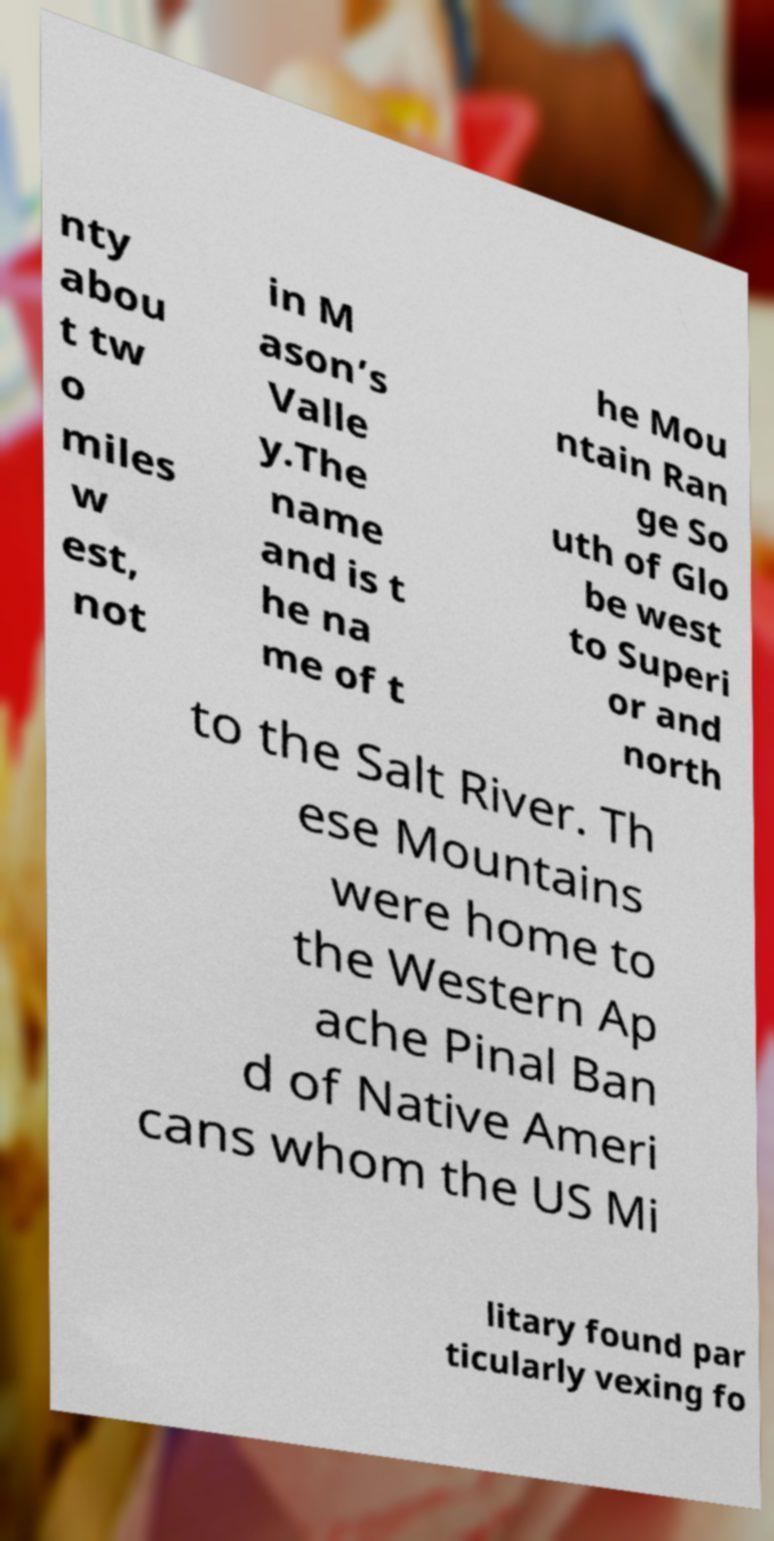There's text embedded in this image that I need extracted. Can you transcribe it verbatim? nty abou t tw o miles w est, not in M ason’s Valle y.The name and is t he na me of t he Mou ntain Ran ge So uth of Glo be west to Superi or and north to the Salt River. Th ese Mountains were home to the Western Ap ache Pinal Ban d of Native Ameri cans whom the US Mi litary found par ticularly vexing fo 